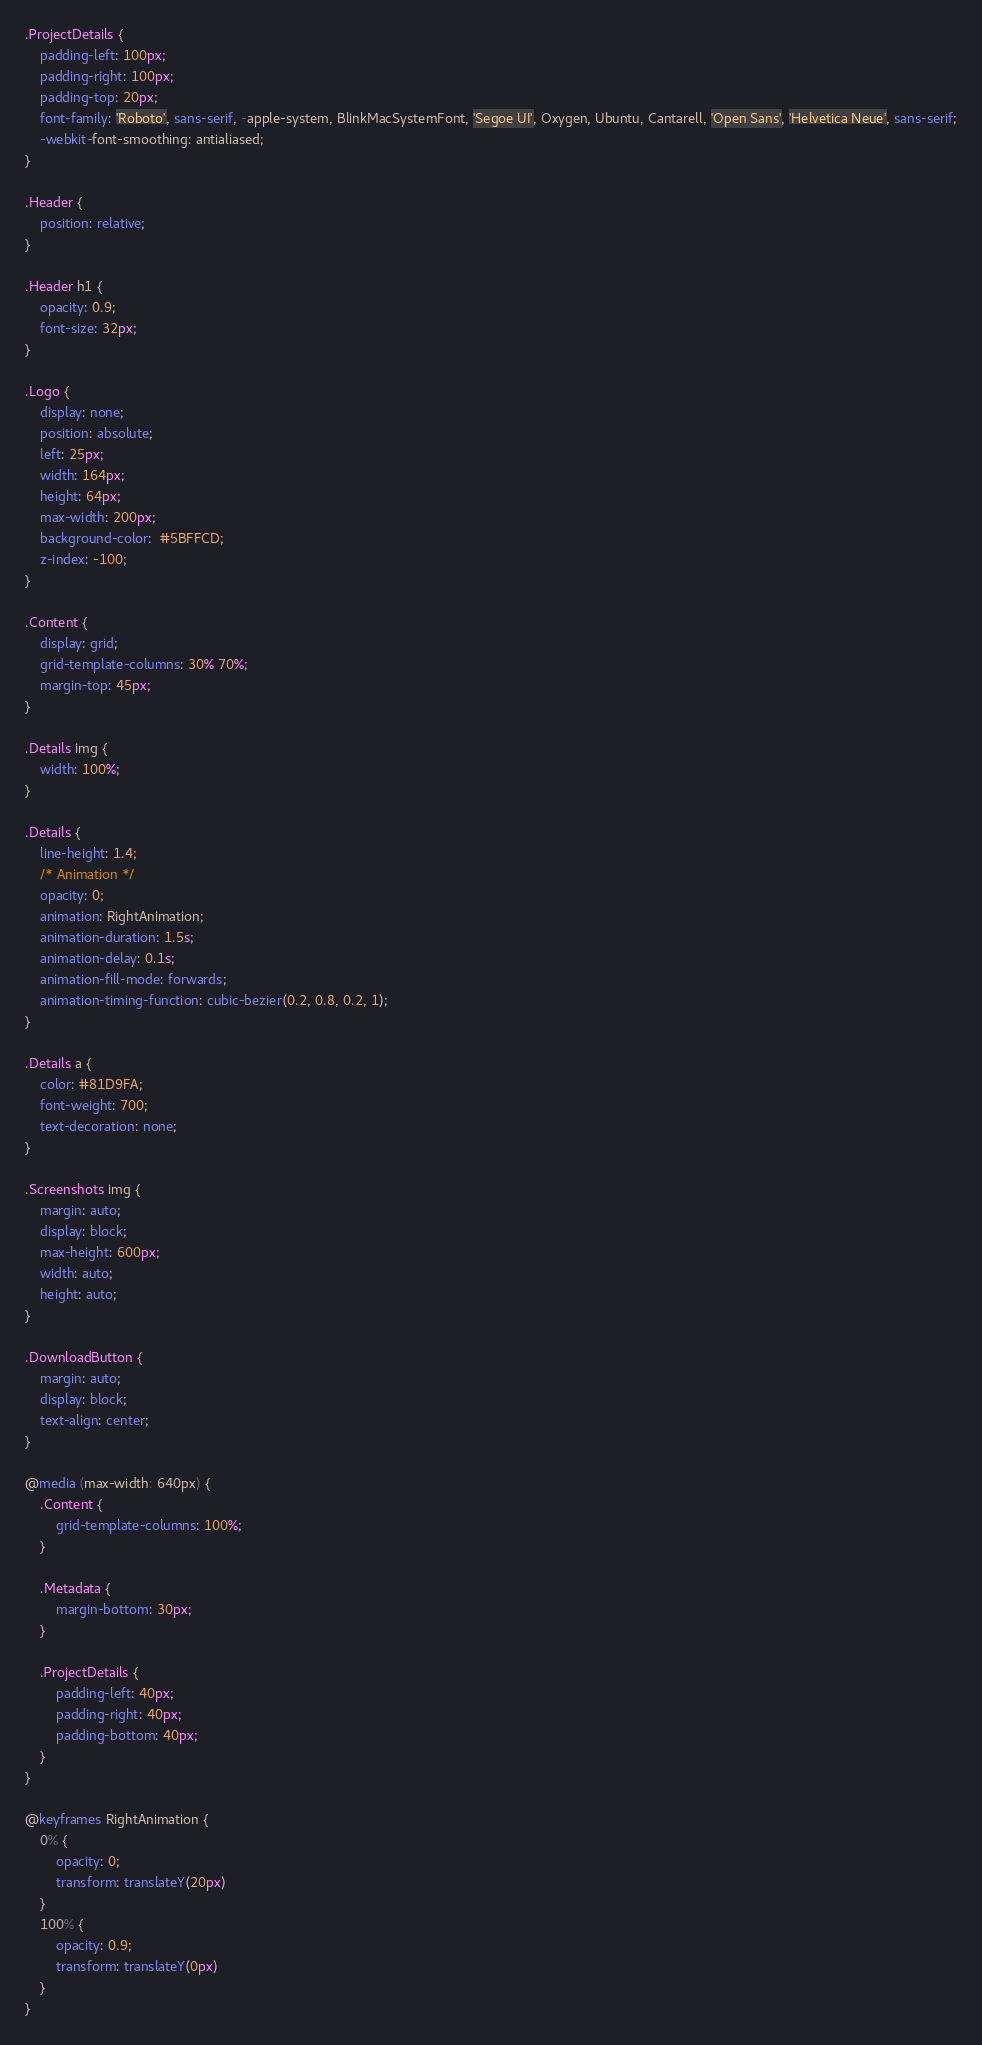Convert code to text. <code><loc_0><loc_0><loc_500><loc_500><_CSS_>.ProjectDetails {
    padding-left: 100px;
    padding-right: 100px;
    padding-top: 20px;
    font-family: 'Roboto', sans-serif, -apple-system, BlinkMacSystemFont, 'Segoe UI', Oxygen, Ubuntu, Cantarell, 'Open Sans', 'Helvetica Neue', sans-serif;
    -webkit-font-smoothing: antialiased;
}

.Header {
    position: relative;
}
  
.Header h1 {
    opacity: 0.9;
    font-size: 32px;
}
  
.Logo {
    display: none;
    position: absolute;
    left: 25px;
    width: 164px;
    height: 64px;
    max-width: 200px;
    background-color:  #5BFFCD;
    z-index: -100;
}

.Content {
    display: grid;
    grid-template-columns: 30% 70%;
    margin-top: 45px;
}

.Details img {
    width: 100%;
}

.Details {
    line-height: 1.4;
    /* Animation */
    opacity: 0;
    animation: RightAnimation;
    animation-duration: 1.5s;
    animation-delay: 0.1s;
    animation-fill-mode: forwards;
    animation-timing-function: cubic-bezier(0.2, 0.8, 0.2, 1);
}

.Details a {
    color: #81D9FA;
    font-weight: 700;
    text-decoration: none;
}

.Screenshots img {
    margin: auto;
    display: block;
    max-height: 600px;
    width: auto;
    height: auto;
}

.DownloadButton {
    margin: auto;
    display: block;
    text-align: center;
}

@media (max-width: 640px) {
    .Content {
        grid-template-columns: 100%;
    }

    .Metadata {
        margin-bottom: 30px;
    }

    .ProjectDetails {
        padding-left: 40px;
        padding-right: 40px;
        padding-bottom: 40px;
    }
}

@keyframes RightAnimation {
    0% {
        opacity: 0;
        transform: translateY(20px)
    }
    100% {
        opacity: 0.9;
        transform: translateY(0px)
    }
}</code> 